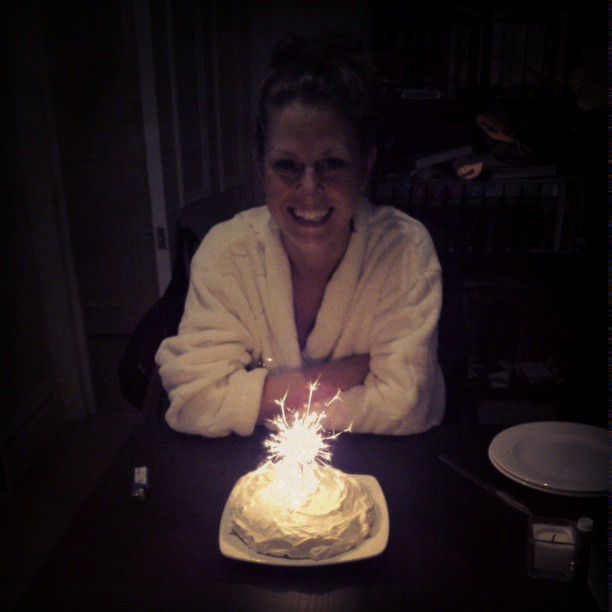Can you tell me about the mood of the birthday person? The birthday person seems joyous and delighted, beaming a wide smile as she sees her birthday cake. The intimate setting suggests a cozy, personal celebration. 